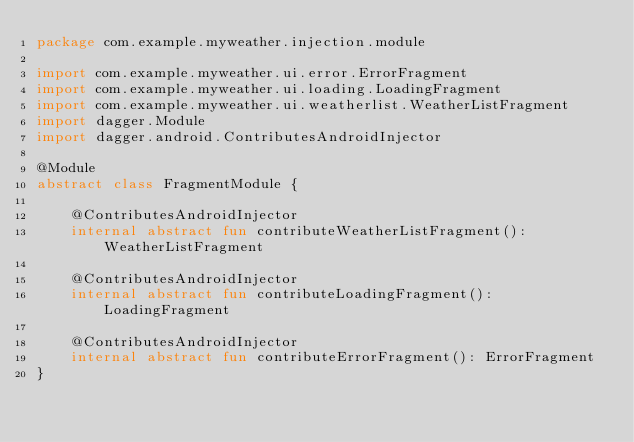Convert code to text. <code><loc_0><loc_0><loc_500><loc_500><_Kotlin_>package com.example.myweather.injection.module

import com.example.myweather.ui.error.ErrorFragment
import com.example.myweather.ui.loading.LoadingFragment
import com.example.myweather.ui.weatherlist.WeatherListFragment
import dagger.Module
import dagger.android.ContributesAndroidInjector

@Module
abstract class FragmentModule {

    @ContributesAndroidInjector
    internal abstract fun contributeWeatherListFragment(): WeatherListFragment

    @ContributesAndroidInjector
    internal abstract fun contributeLoadingFragment(): LoadingFragment

    @ContributesAndroidInjector
    internal abstract fun contributeErrorFragment(): ErrorFragment
}</code> 